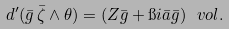Convert formula to latex. <formula><loc_0><loc_0><loc_500><loc_500>d ^ { \prime } ( \bar { g } \, \bar { \zeta } \wedge \theta ) = ( Z \bar { g } + \i i \bar { a } \bar { g } ) \, \ v o l .</formula> 